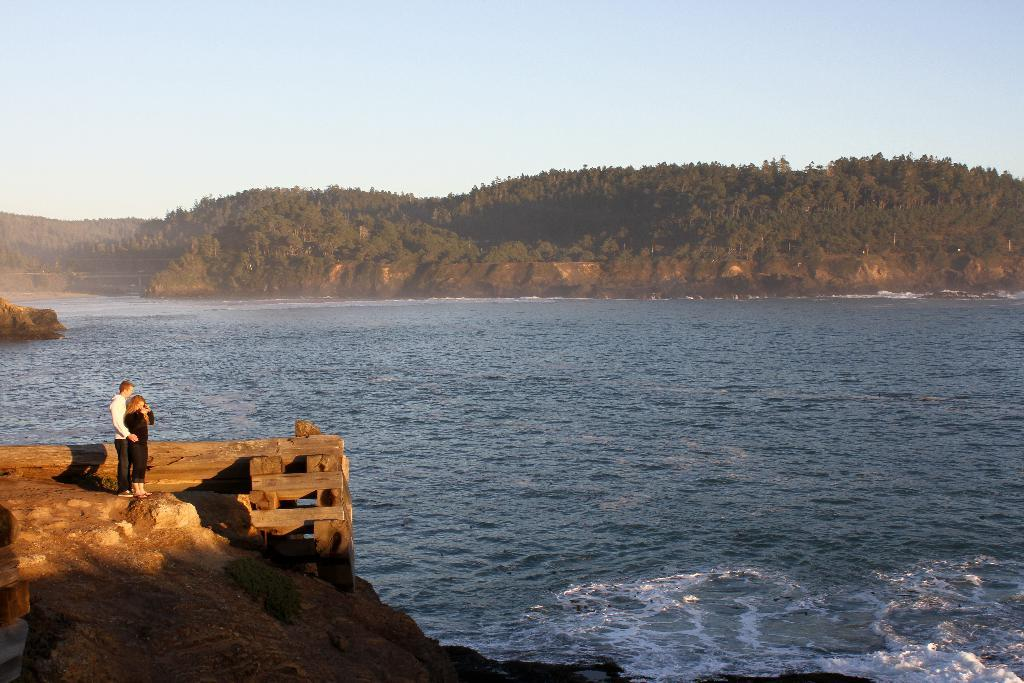Who is present in the image? There is a couple in the image. Where are the couple standing? The couple is standing on a rock. What can be seen in the background of the image? There is water and mountains visible in the image. What type of pets are visible in the image? There are no pets present in the image. How many houses can be seen in the image? There are no houses present in the image. 